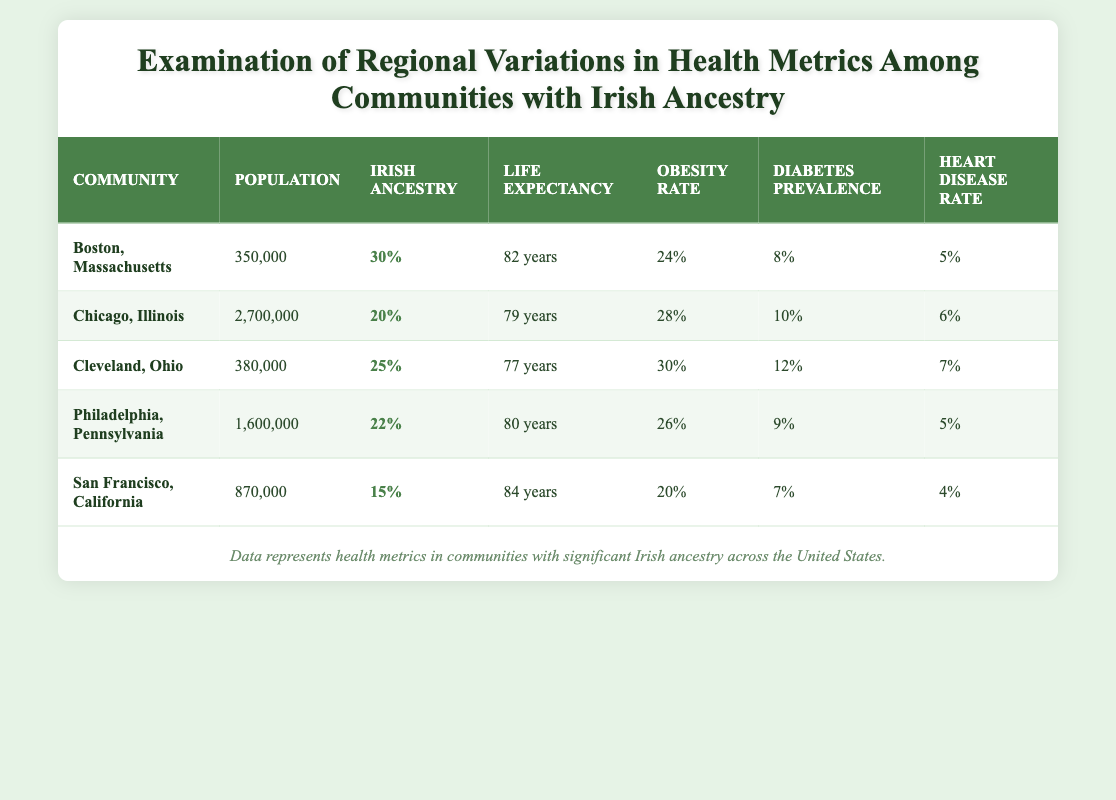What community has the highest average life expectancy? Looking at the table, the average life expectancy is highest for San Francisco, California at 84 years.
Answer: San Francisco, California Which community reports the lowest obesity rate? By comparing the obesity rates in the table, San Francisco, California has the lowest obesity rate at 20%.
Answer: San Francisco, California What is the total population of all communities listed? Summing the populations: 350,000 (Boston) + 2,700,000 (Chicago) + 380,000 (Cleveland) + 1,600,000 (Philadelphia) + 870,000 (San Francisco) = 5,900,000.
Answer: 5,900,000 Is the diabetes prevalence higher in Chicago than in Boston? Chicago has a diabetes prevalence of 10%, while Boston has 8%. Since 10% is greater than 8%, the statement is true.
Answer: Yes What is the average heart disease rate among the communities? The heart disease rates are: 5 (Boston) + 6 (Chicago) + 7 (Cleveland) + 5 (Philadelphia) + 4 (San Francisco) = 27. There are 5 communities, so the average is 27/5 = 5.4.
Answer: 5.4 